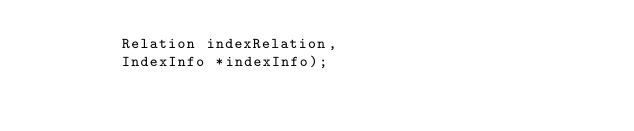<code> <loc_0><loc_0><loc_500><loc_500><_SQL_>         Relation indexRelation,
         IndexInfo *indexInfo);
</code> 